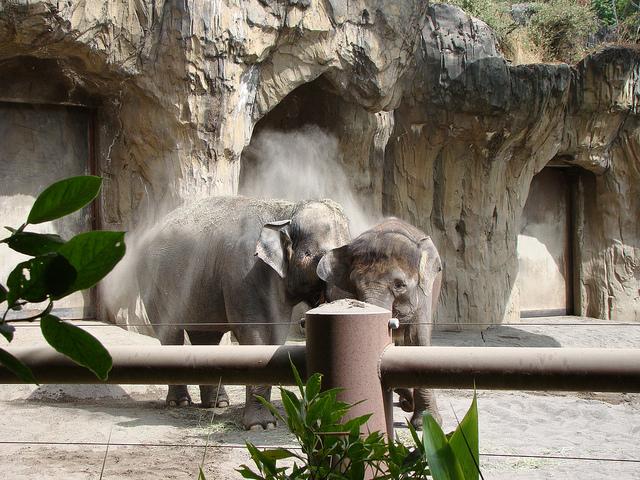Is there water in this photo?
Concise answer only. Yes. How many elephants are in this photo?
Answer briefly. 2. What time is it?
Concise answer only. Midday. 